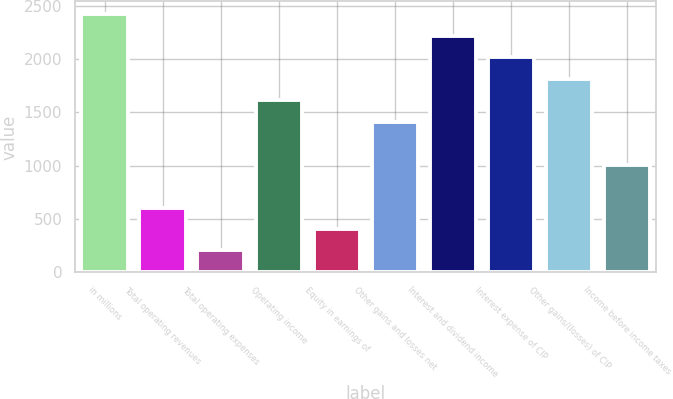Convert chart to OTSL. <chart><loc_0><loc_0><loc_500><loc_500><bar_chart><fcel>in millions<fcel>Total operating revenues<fcel>Total operating expenses<fcel>Operating income<fcel>Equity in earnings of<fcel>Other gains and losses net<fcel>Interest and dividend income<fcel>Interest expense of CIP<fcel>Other gains/(losses) of CIP<fcel>Income before income taxes<nl><fcel>2419.94<fcel>606.71<fcel>203.77<fcel>1614.06<fcel>405.24<fcel>1412.59<fcel>2218.47<fcel>2017<fcel>1815.53<fcel>1009.65<nl></chart> 